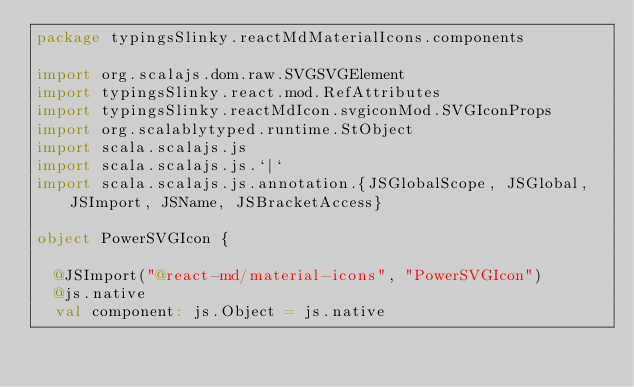Convert code to text. <code><loc_0><loc_0><loc_500><loc_500><_Scala_>package typingsSlinky.reactMdMaterialIcons.components

import org.scalajs.dom.raw.SVGSVGElement
import typingsSlinky.react.mod.RefAttributes
import typingsSlinky.reactMdIcon.svgiconMod.SVGIconProps
import org.scalablytyped.runtime.StObject
import scala.scalajs.js
import scala.scalajs.js.`|`
import scala.scalajs.js.annotation.{JSGlobalScope, JSGlobal, JSImport, JSName, JSBracketAccess}

object PowerSVGIcon {
  
  @JSImport("@react-md/material-icons", "PowerSVGIcon")
  @js.native
  val component: js.Object = js.native
  </code> 